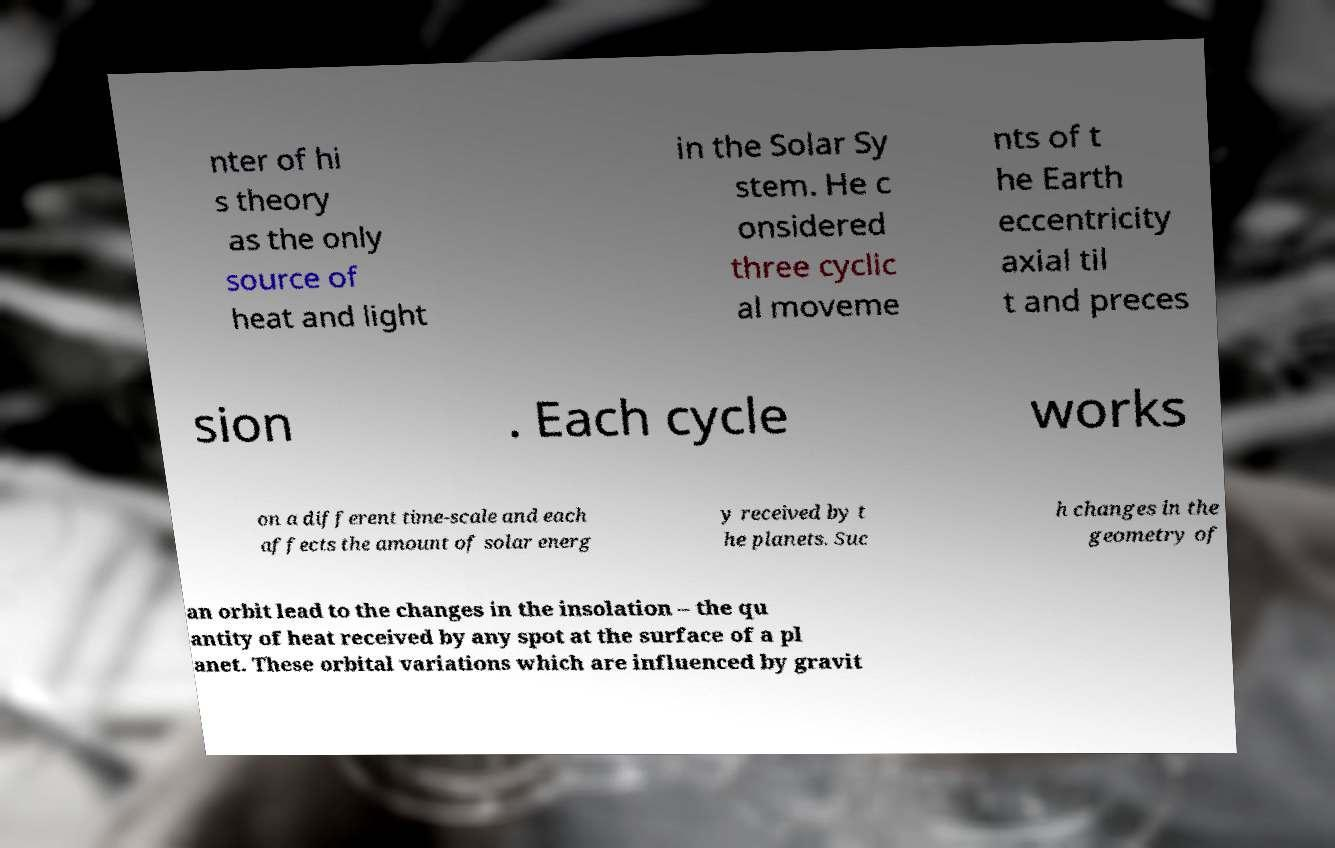Can you read and provide the text displayed in the image?This photo seems to have some interesting text. Can you extract and type it out for me? nter of hi s theory as the only source of heat and light in the Solar Sy stem. He c onsidered three cyclic al moveme nts of t he Earth eccentricity axial til t and preces sion . Each cycle works on a different time-scale and each affects the amount of solar energ y received by t he planets. Suc h changes in the geometry of an orbit lead to the changes in the insolation – the qu antity of heat received by any spot at the surface of a pl anet. These orbital variations which are influenced by gravit 